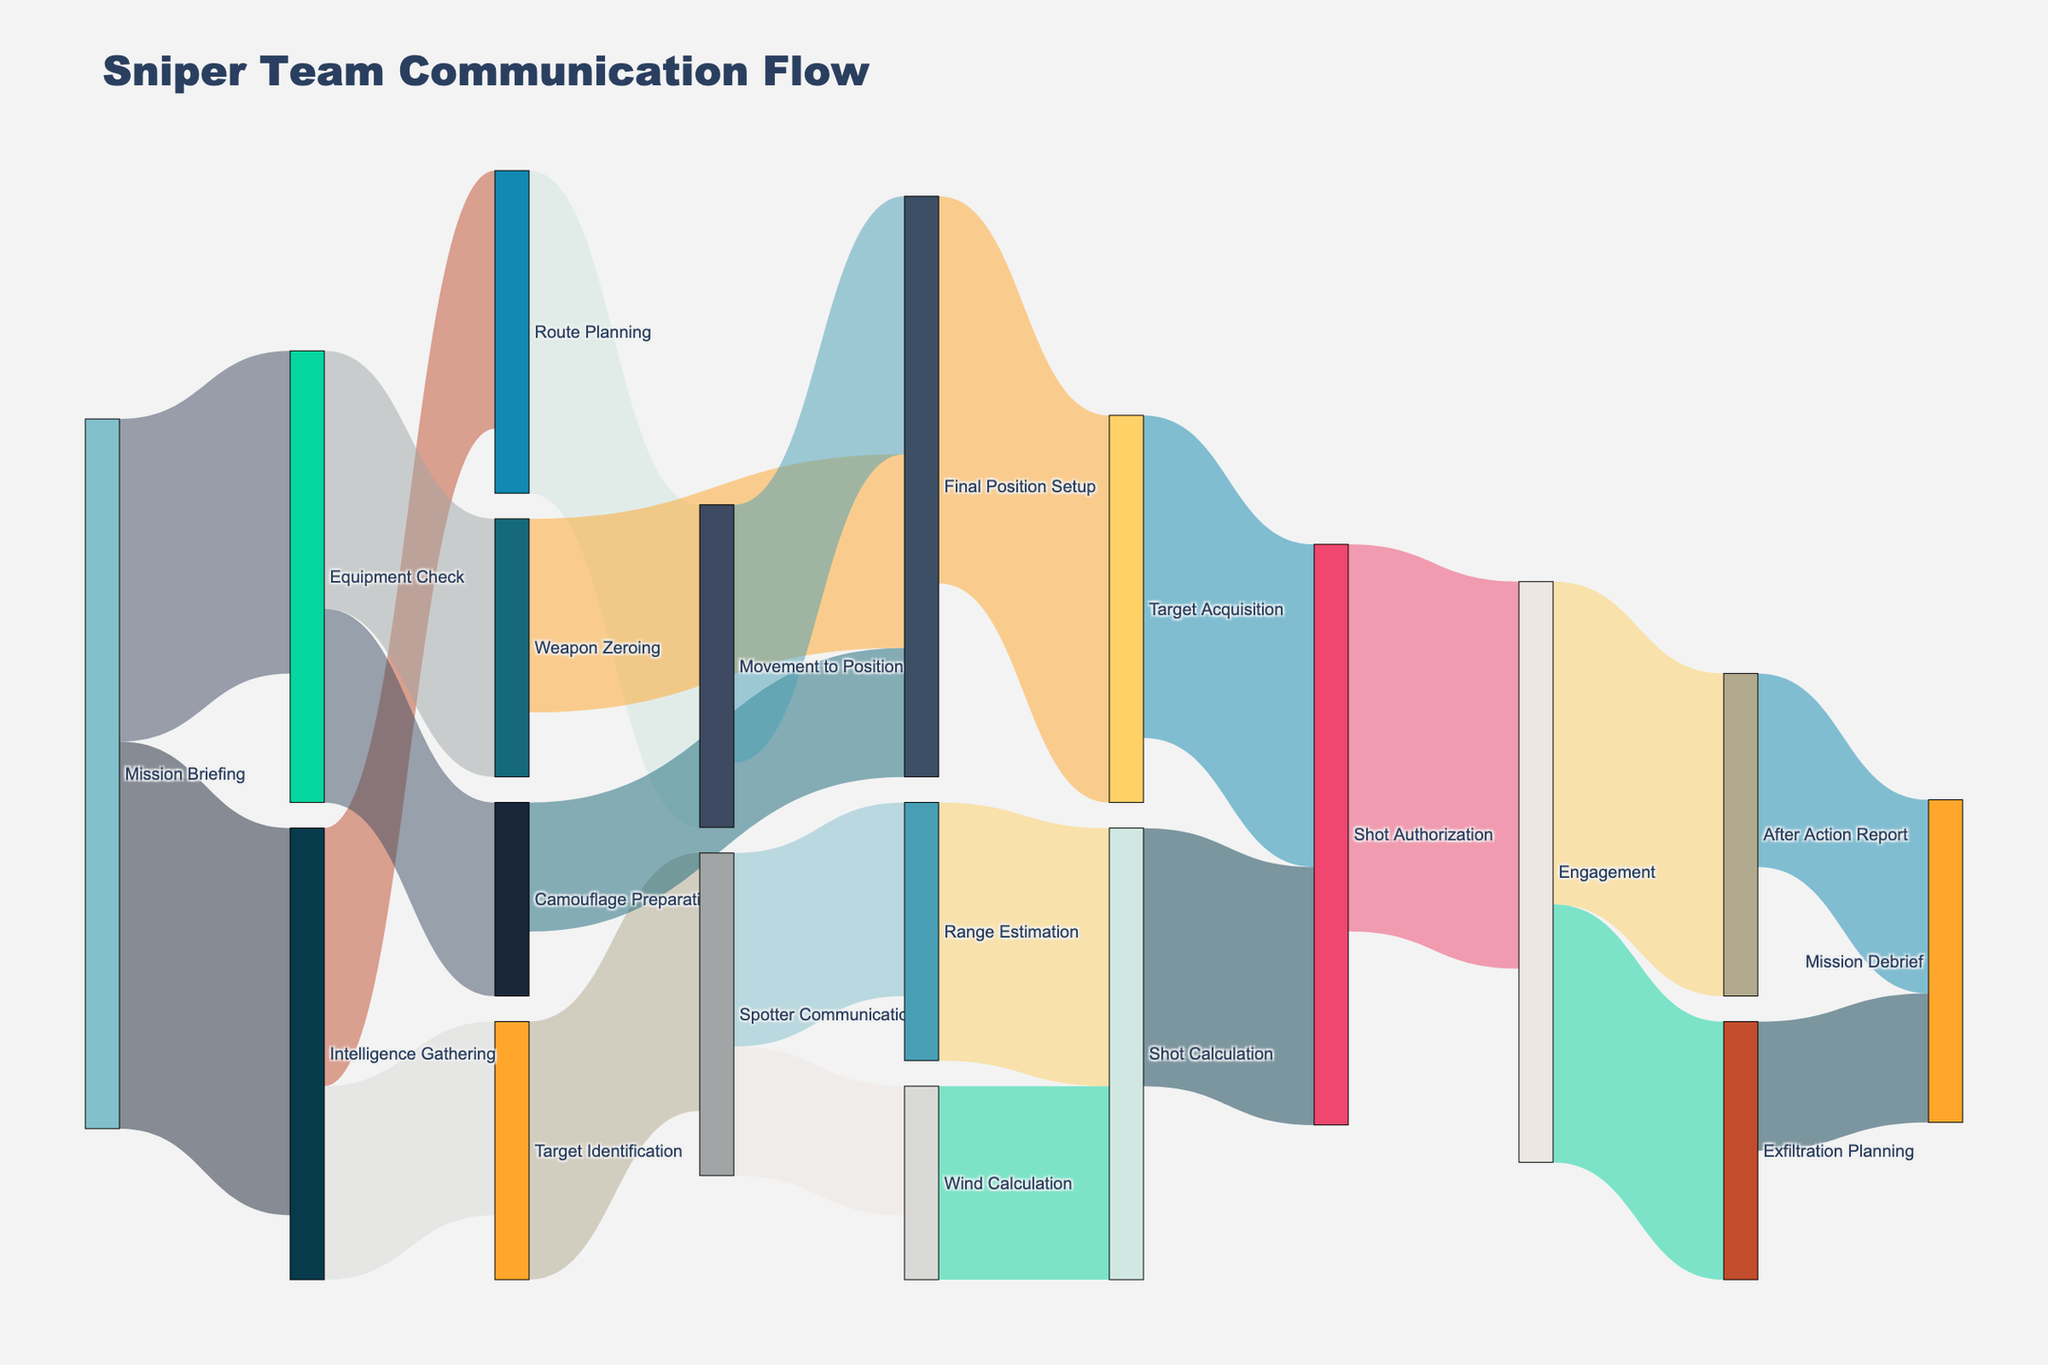what is the title of the diagram? The title is displayed at the top of the figure. It is the most prominent text and represents the main subject of the visualization.
Answer: Sniper Team Communication Flow Which stage has the highest outgoing communication flow? Look at each stage's total outgoing flow represented by the thickness of the links departing from each node. Compare the values to find the highest.
Answer: Mission Briefing How many distinct stages are involved in the operation? Count the unique stages appearing as either source or target nodes. Each node represents a different stage in the operation.
Answer: 18 How many units of communication flow go from Movement to Position to Final Position Setup? Trace the link that starts at Movement to Position and ends at Final Position Setup. The value is indicated on the link connecting these two nodes.
Answer: 20 Which stages directly contribute to the Final Position Setup stage? Identify all the nodes that have outgoing links leading to Final Position Setup. Look at the starting points of these links.
Answer: Weapon Zeroing, Camouflage Preparation, Movement to Position What's the total communication flow between Spotter Communication and Shot Calculation? Combine the communication flow from Spotter Communication to Range Estimation and then from Range Estimation to Shot Calculation. Also, consider flow from Spotter Communication directly to Shot Calculation. Sum these values.
Answer: 15 (Spotter Communication to Range Estimation) + 20 (Range Estimation to Shot Calculation) + 15 (Spotter Communication to Shot Calculation) = 50 Which stage has more communication flow: Camouflage Preparation or Wind Calculation? Compare the total outgoing communication flow values from the nodes representing Camouflage Preparation and Wind Calculation.
Answer: Camouflage Preparation Does Final Position Setup have a direct communication link to Engagement? Observe if there is a direct link or connection (arrow) from Final Position Setup to Engagement.
Answer: No Between Shot Authorization and Engagement, which has a higher outgoing communication flow? Look at the outgoing flows from both Shot Authorization and Engagement nodes and compare their values.
Answer: They are equal What's the primary subsequent stage after Shot Authorization? Identify the stage that receives the most significant communication flow from Shot Authorization by observing the width of the outgoing links.
Answer: Engagement 